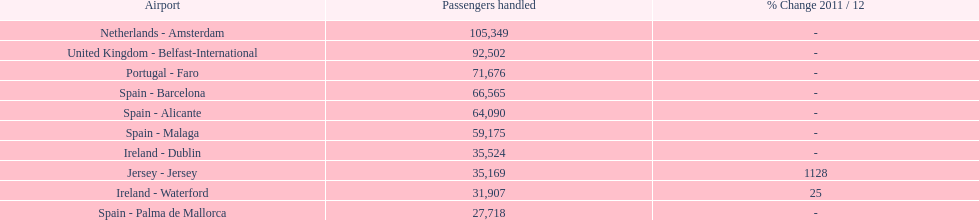Could you parse the entire table as a dict? {'header': ['Airport', 'Passengers handled', '% Change 2011 / 12'], 'rows': [['Netherlands - Amsterdam', '105,349', '-'], ['United Kingdom - Belfast-International', '92,502', '-'], ['Portugal - Faro', '71,676', '-'], ['Spain - Barcelona', '66,565', '-'], ['Spain - Alicante', '64,090', '-'], ['Spain - Malaga', '59,175', '-'], ['Ireland - Dublin', '35,524', '-'], ['Jersey - Jersey', '35,169', '1128'], ['Ireland - Waterford', '31,907', '25'], ['Spain - Palma de Mallorca', '27,718', '-']]} Where is the most popular destination for passengers leaving london southend airport? Netherlands - Amsterdam. 